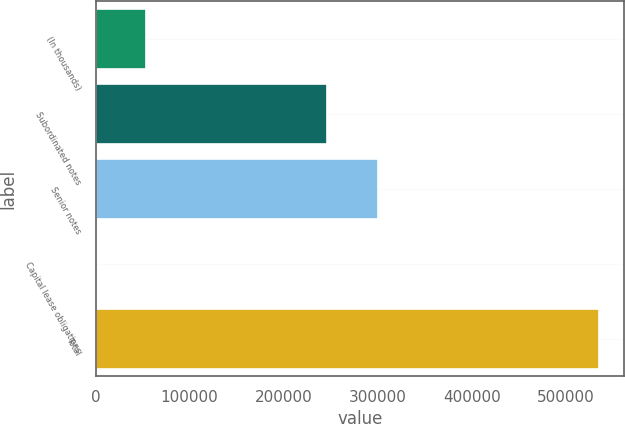<chart> <loc_0><loc_0><loc_500><loc_500><bar_chart><fcel>(In thousands)<fcel>Subordinated notes<fcel>Senior notes<fcel>Capital lease obligations<fcel>Total<nl><fcel>54151<fcel>246550<fcel>299961<fcel>740<fcel>534850<nl></chart> 